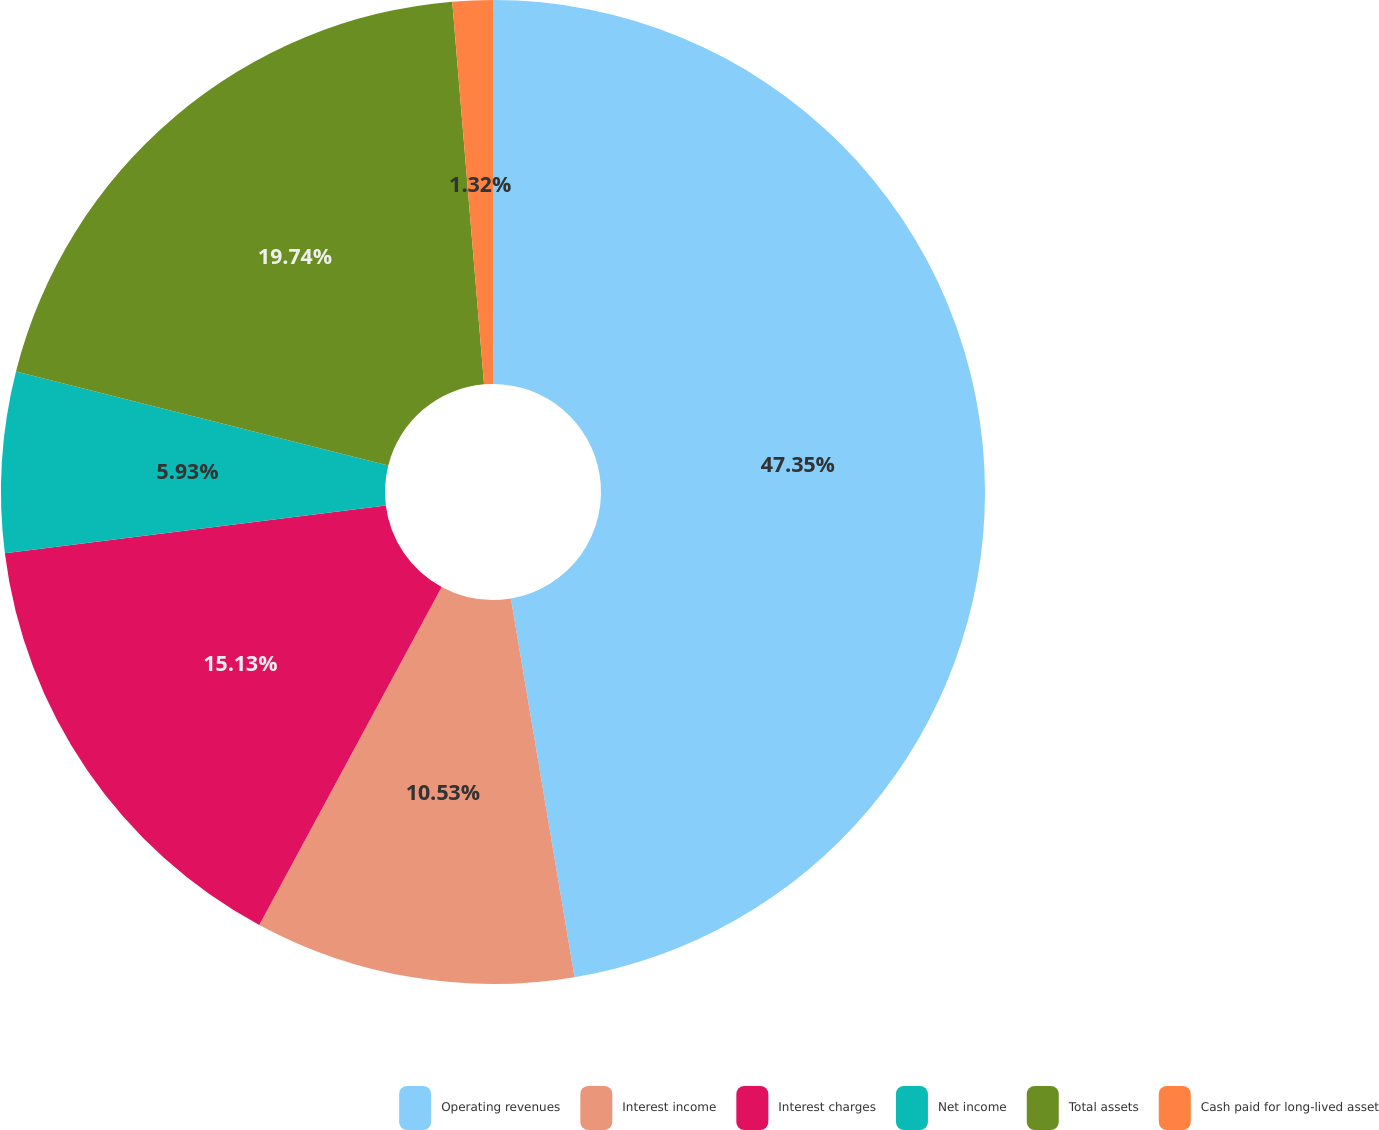Convert chart. <chart><loc_0><loc_0><loc_500><loc_500><pie_chart><fcel>Operating revenues<fcel>Interest income<fcel>Interest charges<fcel>Net income<fcel>Total assets<fcel>Cash paid for long-lived asset<nl><fcel>47.35%<fcel>10.53%<fcel>15.13%<fcel>5.93%<fcel>19.74%<fcel>1.32%<nl></chart> 